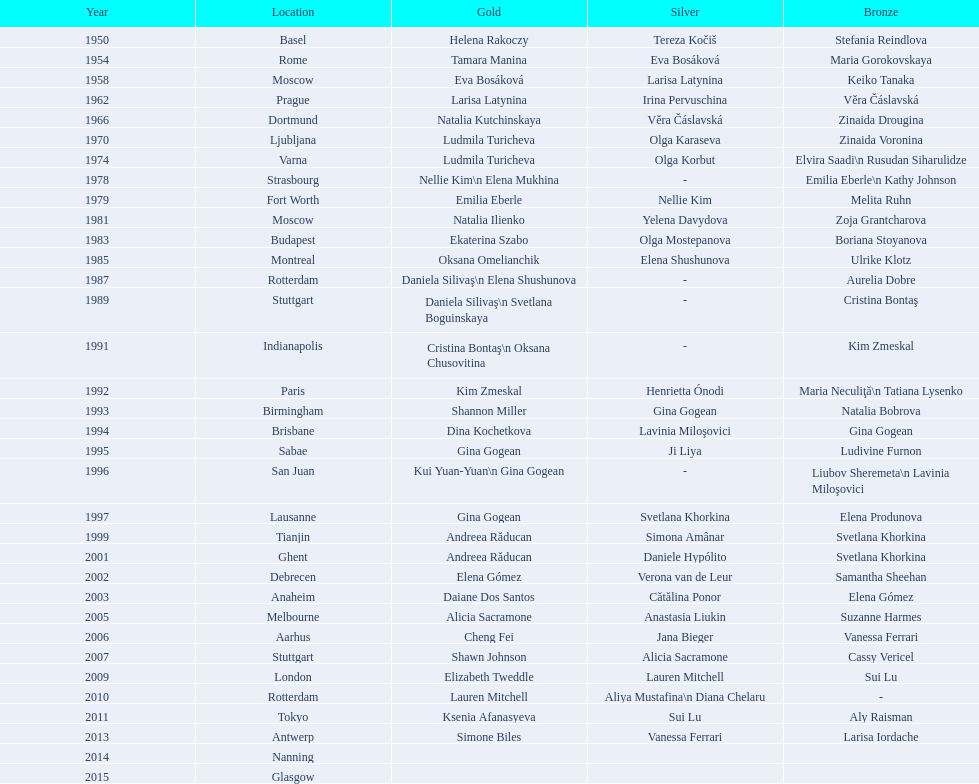What is the number of times a brazilian has won a medal? 2. 